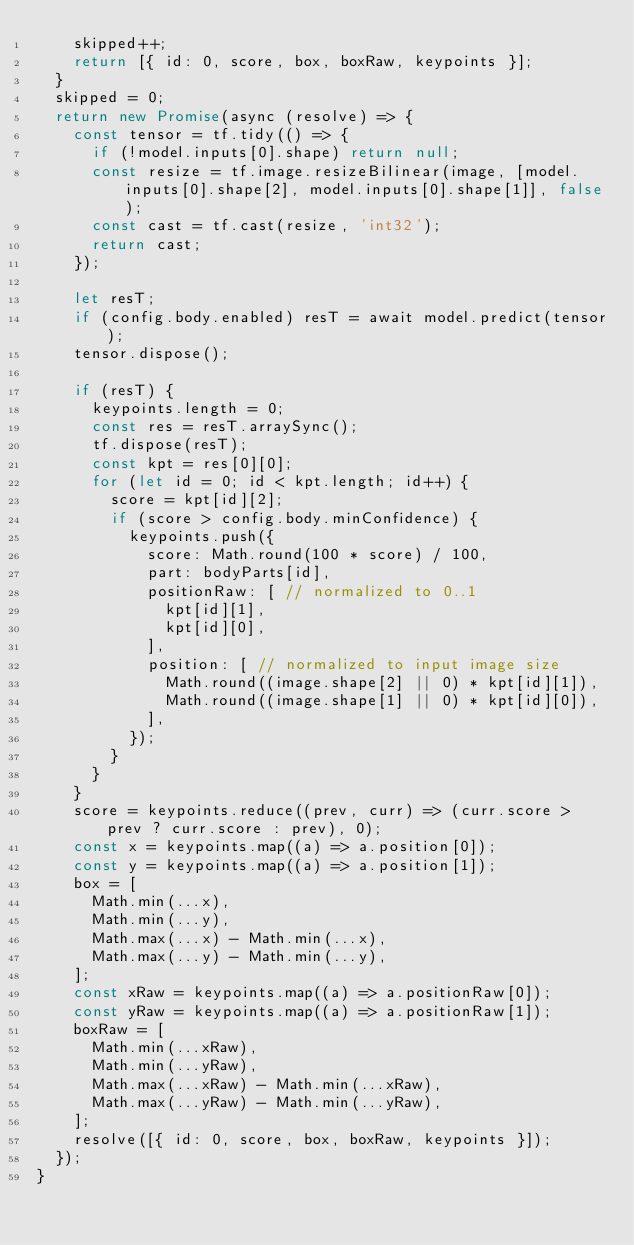<code> <loc_0><loc_0><loc_500><loc_500><_TypeScript_>    skipped++;
    return [{ id: 0, score, box, boxRaw, keypoints }];
  }
  skipped = 0;
  return new Promise(async (resolve) => {
    const tensor = tf.tidy(() => {
      if (!model.inputs[0].shape) return null;
      const resize = tf.image.resizeBilinear(image, [model.inputs[0].shape[2], model.inputs[0].shape[1]], false);
      const cast = tf.cast(resize, 'int32');
      return cast;
    });

    let resT;
    if (config.body.enabled) resT = await model.predict(tensor);
    tensor.dispose();

    if (resT) {
      keypoints.length = 0;
      const res = resT.arraySync();
      tf.dispose(resT);
      const kpt = res[0][0];
      for (let id = 0; id < kpt.length; id++) {
        score = kpt[id][2];
        if (score > config.body.minConfidence) {
          keypoints.push({
            score: Math.round(100 * score) / 100,
            part: bodyParts[id],
            positionRaw: [ // normalized to 0..1
              kpt[id][1],
              kpt[id][0],
            ],
            position: [ // normalized to input image size
              Math.round((image.shape[2] || 0) * kpt[id][1]),
              Math.round((image.shape[1] || 0) * kpt[id][0]),
            ],
          });
        }
      }
    }
    score = keypoints.reduce((prev, curr) => (curr.score > prev ? curr.score : prev), 0);
    const x = keypoints.map((a) => a.position[0]);
    const y = keypoints.map((a) => a.position[1]);
    box = [
      Math.min(...x),
      Math.min(...y),
      Math.max(...x) - Math.min(...x),
      Math.max(...y) - Math.min(...y),
    ];
    const xRaw = keypoints.map((a) => a.positionRaw[0]);
    const yRaw = keypoints.map((a) => a.positionRaw[1]);
    boxRaw = [
      Math.min(...xRaw),
      Math.min(...yRaw),
      Math.max(...xRaw) - Math.min(...xRaw),
      Math.max(...yRaw) - Math.min(...yRaw),
    ];
    resolve([{ id: 0, score, box, boxRaw, keypoints }]);
  });
}
</code> 